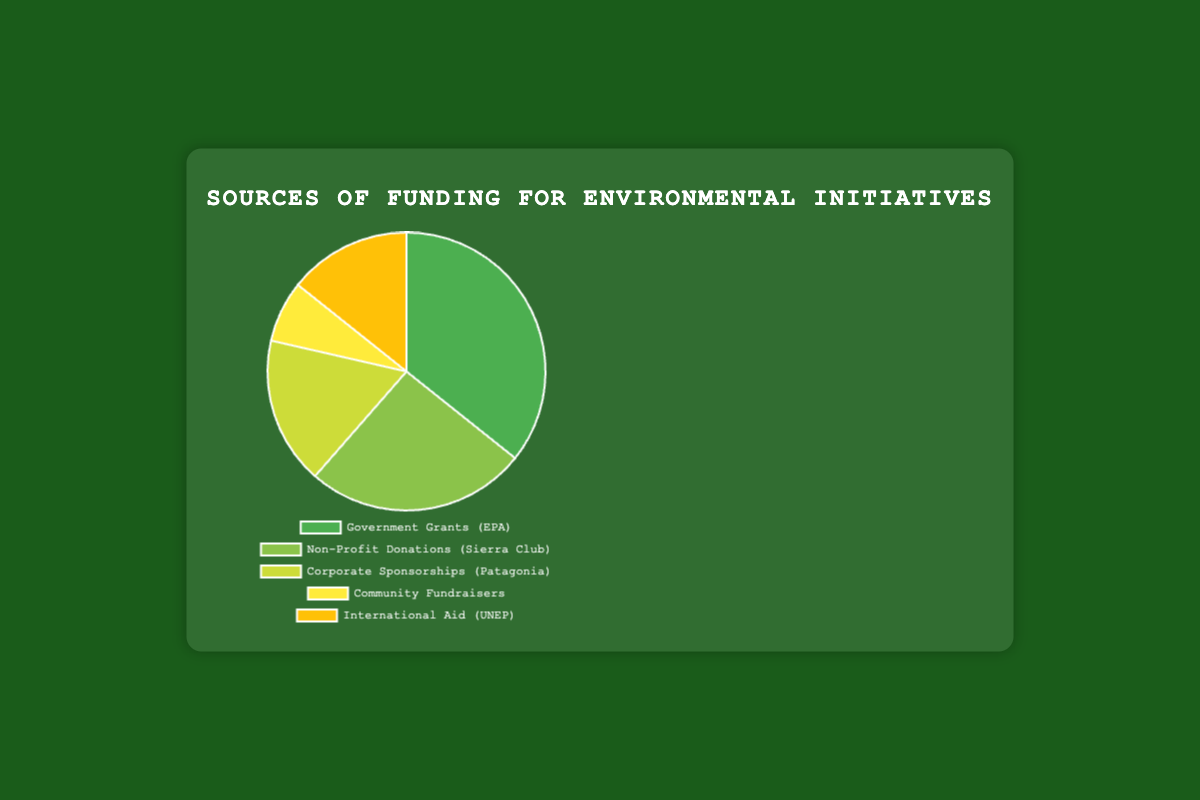What is the total amount of funding from all sources combined? To find the total amount of funding, sum the amounts from all sources: Government Grants ($2,500,000), Non-Profit Donations ($1,800,000), Corporate Sponsorships ($1,200,000), Community Fundraisers ($500,000), International Aid ($1,000,000). The total is $2,500,000 + $1,800,000 + $1,200,000 + $500,000 + $1,000,000 = $7,000,000.
Answer: $7,000,000 Which source provides the largest amount of funding? By comparing the amounts of funding from each source, we see that Government Grants provide the largest amount, which is $2,500,000.
Answer: Government Grants What is the difference between the amounts provided by Government Grants and Corporate Sponsorships? The amount from Government Grants is $2,500,000 and from Corporate Sponsorships is $1,200,000. The difference is $2,500,000 - $1,200,000 = $1,300,000.
Answer: $1,300,000 How much more does the United Nations Environment Programme (UNEP) contribute compared to the Green Earth Community Walkathon? UNEP's contribution is $1,000,000, while the Green Earth Community Walkathon contributes $500,000. The difference is $1,000,000 - $500,000 = $500,000.
Answer: $500,000 What percentage of the total funding is provided by Non-Profit Donations? First, calculate the total funding: $7,000,000. The amount from Non-Profit Donations is $1,800,000. The percentage is ($1,800,000 / $7,000,000) * 100% = 25.71%.
Answer: 25.71% Which funding source provides the least amount? By comparing the amounts, Community Fundraisers provide the least amount which is $500,000.
Answer: Community Fundraisers What is the percentage difference between Corporate Sponsorships and International Aid? The amounts are $1,200,000 for Corporate Sponsorships and $1,000,000 for International Aid. The percentage difference is (($1,200,000 - $1,000,000) / $1,000,000) * 100% = 20%.
Answer: 20% How much more funding does Sierra Club Foundation provide compared to Patagonia? Sierra Club Foundation provides $1,800,000 and Patagonia provides $1,200,000. Therefore, Sierra Club Foundation provides $1,800,000 - $1,200,000 = $600,000 more funding.
Answer: $600,000 What is the combined amount of funding from Corporate Sponsorships and Community Fundraisers? Corporate Sponsorships contribute $1,200,000 and Community Fundraisers contribute $500,000. The combined total is $1,200,000 + $500,000 = $1,700,000.
Answer: $1,700,000 